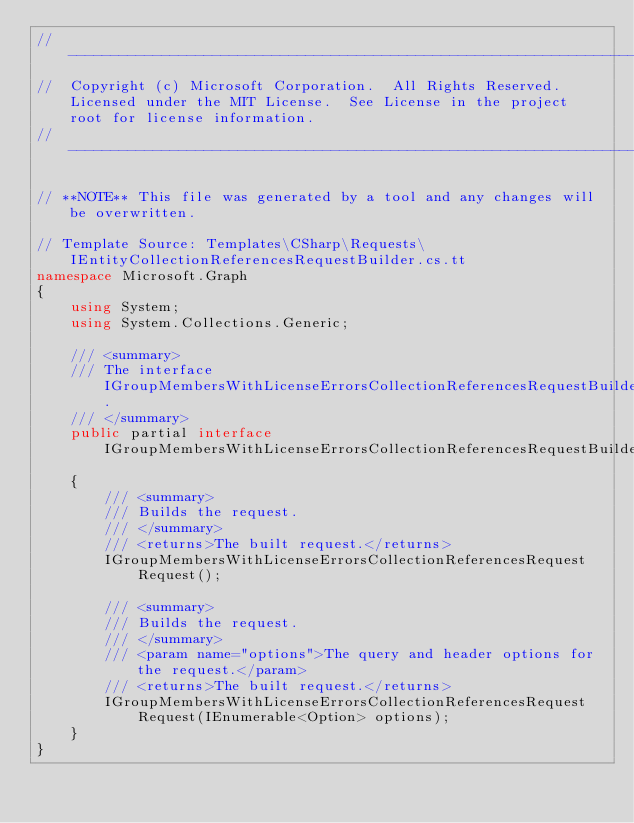<code> <loc_0><loc_0><loc_500><loc_500><_C#_>// ------------------------------------------------------------------------------
//  Copyright (c) Microsoft Corporation.  All Rights Reserved.  Licensed under the MIT License.  See License in the project root for license information.
// ------------------------------------------------------------------------------

// **NOTE** This file was generated by a tool and any changes will be overwritten.

// Template Source: Templates\CSharp\Requests\IEntityCollectionReferencesRequestBuilder.cs.tt
namespace Microsoft.Graph
{
    using System;
    using System.Collections.Generic;

    /// <summary>
    /// The interface IGroupMembersWithLicenseErrorsCollectionReferencesRequestBuilder.
    /// </summary>
    public partial interface IGroupMembersWithLicenseErrorsCollectionReferencesRequestBuilder
    {
        /// <summary>
        /// Builds the request.
        /// </summary>
        /// <returns>The built request.</returns>
        IGroupMembersWithLicenseErrorsCollectionReferencesRequest Request();

        /// <summary>
        /// Builds the request.
        /// </summary>
        /// <param name="options">The query and header options for the request.</param>
        /// <returns>The built request.</returns>
        IGroupMembersWithLicenseErrorsCollectionReferencesRequest Request(IEnumerable<Option> options);
    }
}
</code> 